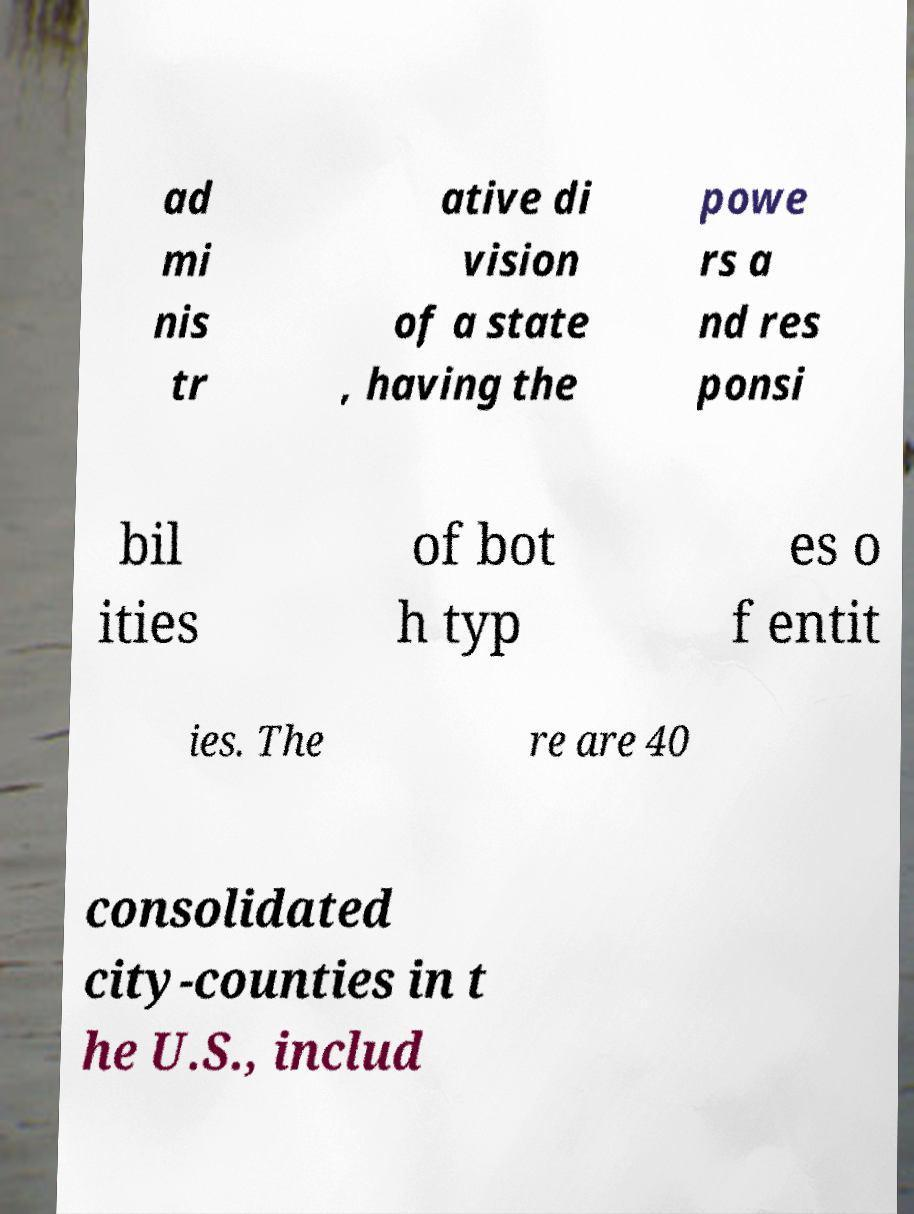For documentation purposes, I need the text within this image transcribed. Could you provide that? ad mi nis tr ative di vision of a state , having the powe rs a nd res ponsi bil ities of bot h typ es o f entit ies. The re are 40 consolidated city-counties in t he U.S., includ 